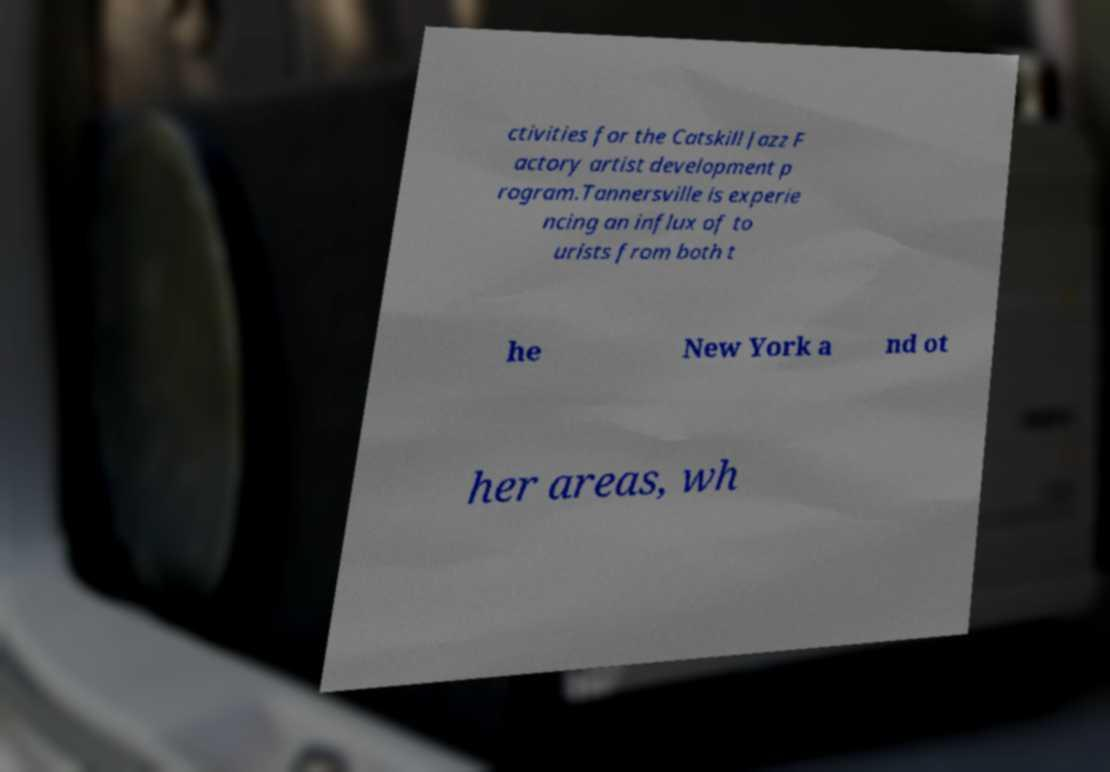Could you assist in decoding the text presented in this image and type it out clearly? ctivities for the Catskill Jazz F actory artist development p rogram.Tannersville is experie ncing an influx of to urists from both t he New York a nd ot her areas, wh 